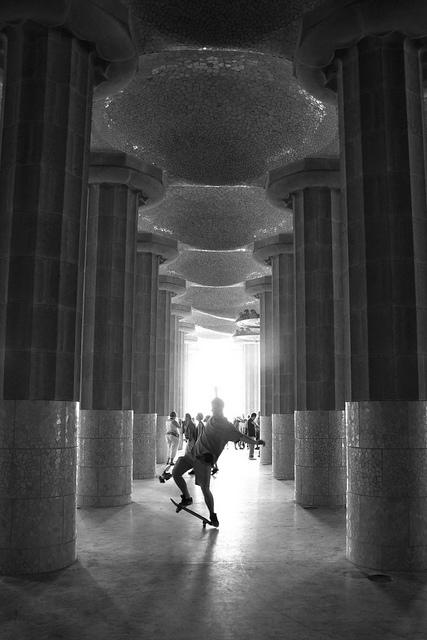What sport is shown?
Answer briefly. Skateboarding. Does this look like a place that would allow skateboarding?
Be succinct. No. What does this building remind you of?
Write a very short answer. Museum. 